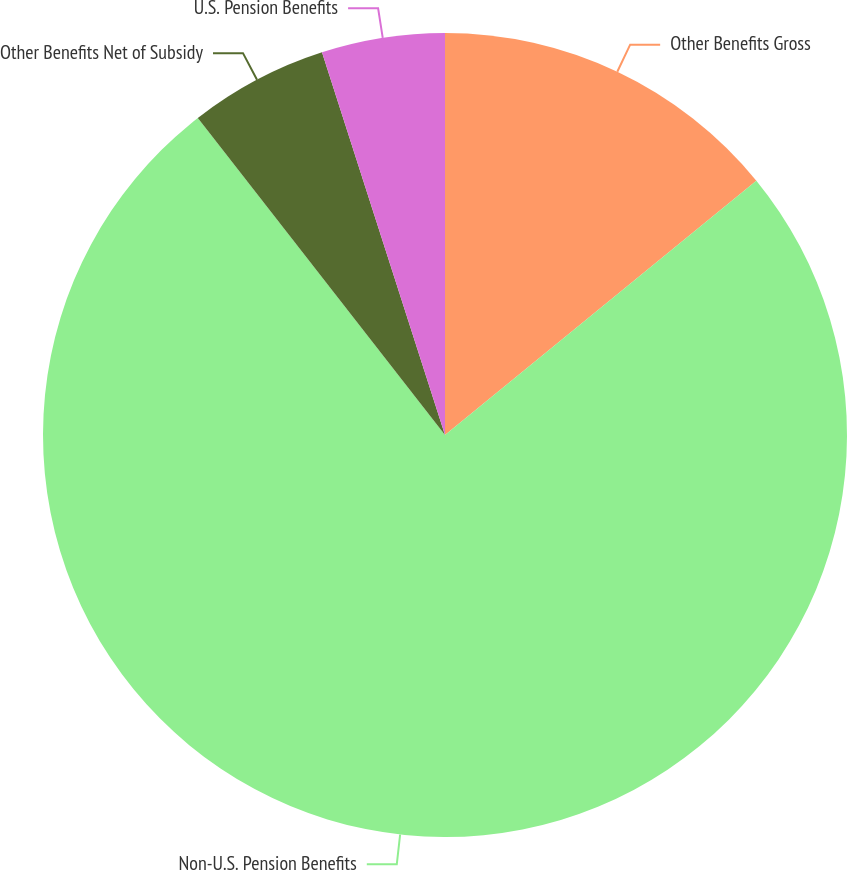Convert chart to OTSL. <chart><loc_0><loc_0><loc_500><loc_500><pie_chart><fcel>Other Benefits Gross<fcel>Non-U.S. Pension Benefits<fcel>Other Benefits Net of Subsidy<fcel>U.S. Pension Benefits<nl><fcel>14.1%<fcel>75.36%<fcel>5.59%<fcel>4.95%<nl></chart> 